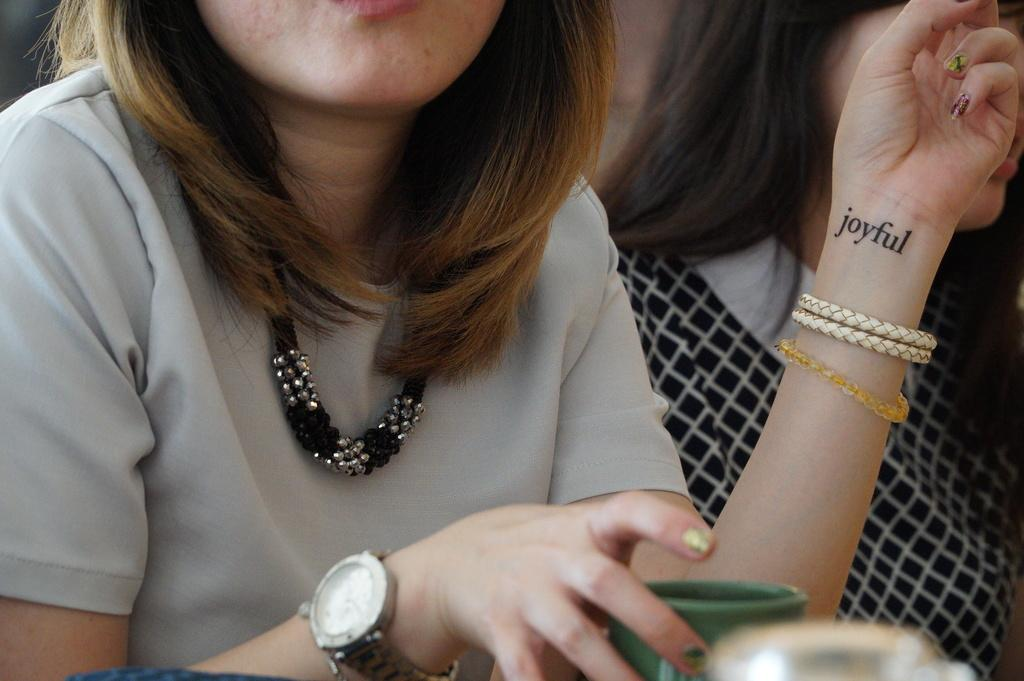Provide a one-sentence caption for the provided image. A woman with the word joyful tattooed on her wrist is sitting with a mug in front of her. 